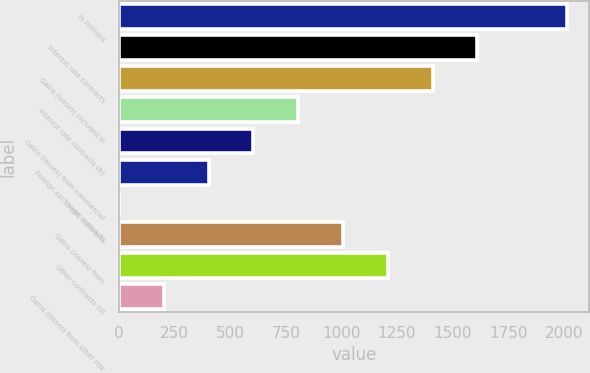Convert chart. <chart><loc_0><loc_0><loc_500><loc_500><bar_chart><fcel>In millions<fcel>Interest rate contracts<fcel>Gains (losses) included in<fcel>Interest rate contracts (b)<fcel>Gains (losses) from commercial<fcel>Foreign exchange contracts<fcel>Credit contracts<fcel>Gains (losses) from<fcel>Other contracts (d)<fcel>Gains (losses) from other risk<nl><fcel>2014<fcel>1611.4<fcel>1410.1<fcel>806.2<fcel>604.9<fcel>403.6<fcel>1<fcel>1007.5<fcel>1208.8<fcel>202.3<nl></chart> 